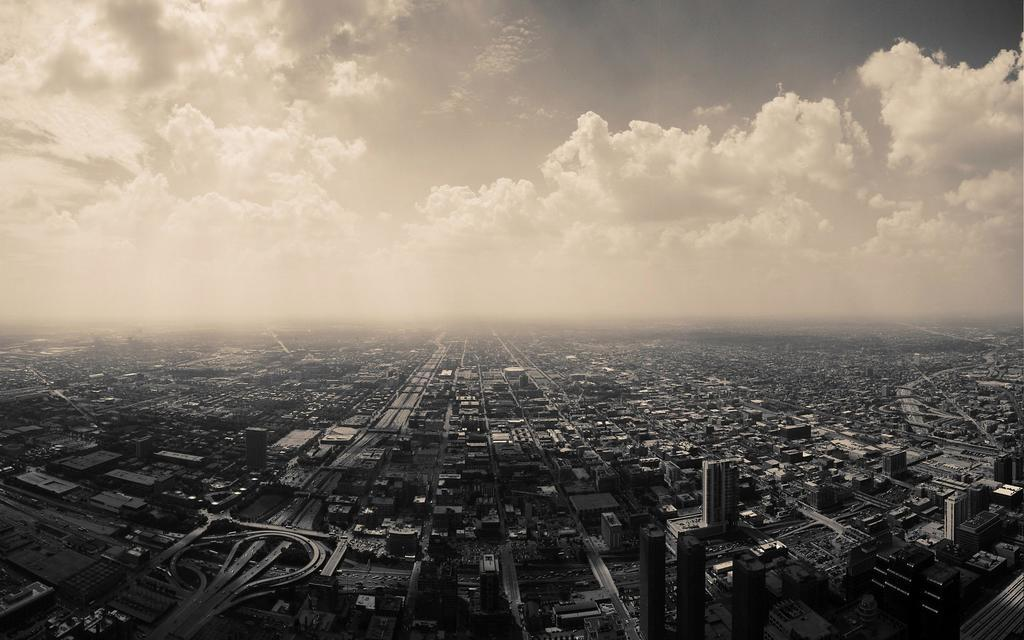What type of view is shown in the image? The image is an aerial view of a city. What structures can be seen in the image? There are buildings and houses in the image. What type of vegetation is present in the image? There are trees and plants in the image. What is visible at the top of the image? The sky is visible at the top of the image. What is the condition of the sky in the image? The sky is cloudy in the image. Can you tell me which vein is responsible for the city's water supply in the image? There is no specific vein mentioned or depicted in the image; it is an aerial view of a city with buildings, houses, trees, plants, and a cloudy sky. Is there any indication of an attack on the city in the image? There is no indication of an attack or any other event in the image; it is a simple aerial view of a city. 